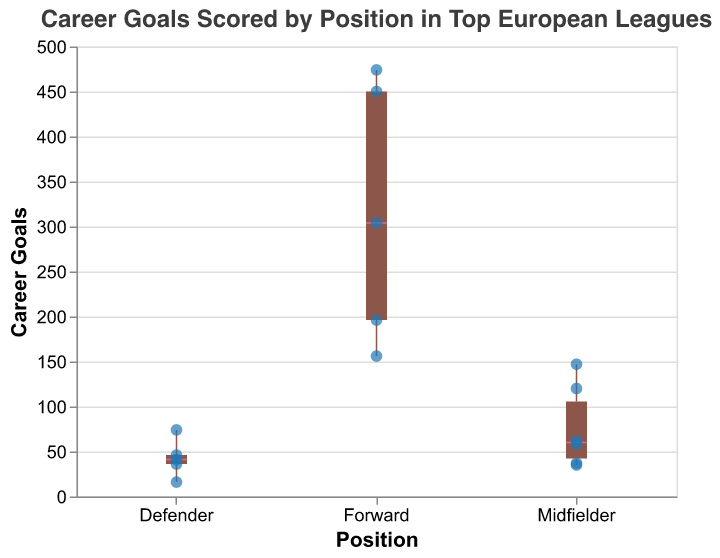What is the title of the plot? The title of the plot is located at the top, it reads "Career Goals Scored by Position in Top European Leagues".
Answer: Career Goals Scored by Position in Top European Leagues Which position has the highest median career goals? Looking at the plot, the median is represented by the bold horizontal line within the box. The forwards category has the highest median line compared to midfielders and defenders.
Answer: Forwards Who is the player with the most career goals as a defender and how many goals has he scored? Among the scatter points in the defenders' section, the highest point is for Sergio Ramos who has scored 74 goals.
Answer: Sergio Ramos, 74 What is the range of goals scored by midfielders? The range can be determined from the minimum and maximum points in the box plot for midfielders. The data ranges from Andres Iniesta with 35 goals to Frank Lampard with 147 goals.
Answer: 35 to 147 How many data points are there for the position of forwards? By counting the scatter points in the forwards section, we see there are 5 different players represented.
Answer: 5 What is the interquartile range of goals for defenders? The interquartile range (IQR) is the difference between the third quartile (Q3) and the first quartile (Q1). It can be determined from the box but the exact values aren't shown, so we look at the names provided. The approximate IQR is from Franz Beckenbauer (36) to Sergio Ramos (74).
Answer: Approximately 36 to 74 Which midfielder has scored the least goals, and what is the value? The lowest scatter point in the midfielders' section corresponds to Andres Iniesta, who has scored the least with 35 goals.
Answer: Andres Iniesta, 35 Compare the median goals scored by forwards and midfielders. Which group has the higher median and by how much? By looking at the median lines within the boxes, forwards have a higher median than midfielders. The exact median values aren't given, but from the scatter points, we can estimate that the median for forwards is around Cristiano Ronaldo's value (450), and midfielders around Steven Gerrard’s values (120). Thus, forwards have a higher median by around 330 goals.
Answer: Forwards, approximately 330 goals Which position appears to have the greatest variability in goal scoring, and why? Variability can be assessed by the length of the box plot (interquartile range) and the range (distance between the lowest and highest points). Forwards have the greatest range with Lionel Messi scoring 474 and the lowest in forwards being Zlatan Ibrahimovic at 156. Hence, they have significant variability.
Answer: Forwards What is the minimum number of goals scored by a defender and which player scored them? By observing the lowest scatter point in the defenders' section, we see that Philip Lahm has the minimum with 16 goals.
Answer: Philip Lahm, 16 